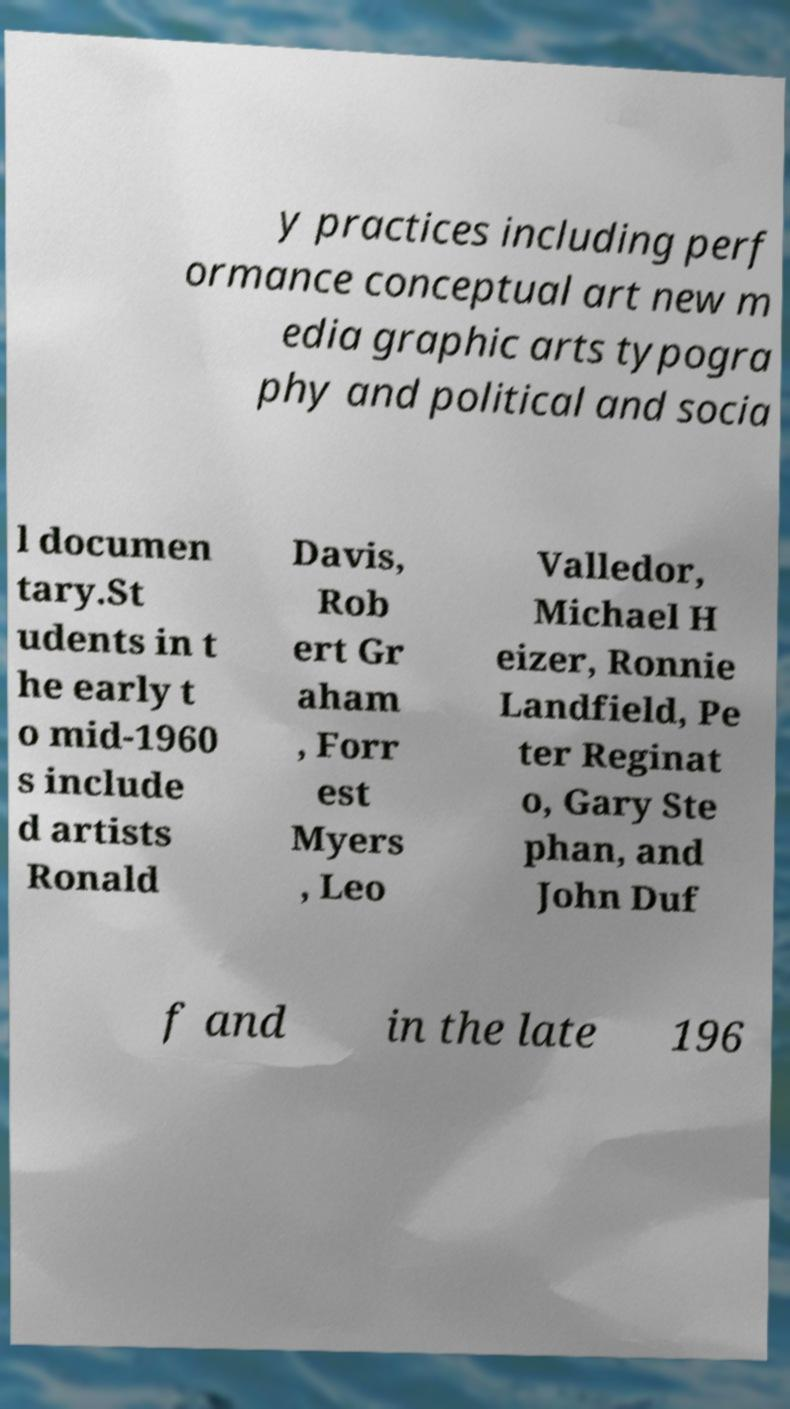There's text embedded in this image that I need extracted. Can you transcribe it verbatim? y practices including perf ormance conceptual art new m edia graphic arts typogra phy and political and socia l documen tary.St udents in t he early t o mid-1960 s include d artists Ronald Davis, Rob ert Gr aham , Forr est Myers , Leo Valledor, Michael H eizer, Ronnie Landfield, Pe ter Reginat o, Gary Ste phan, and John Duf f and in the late 196 